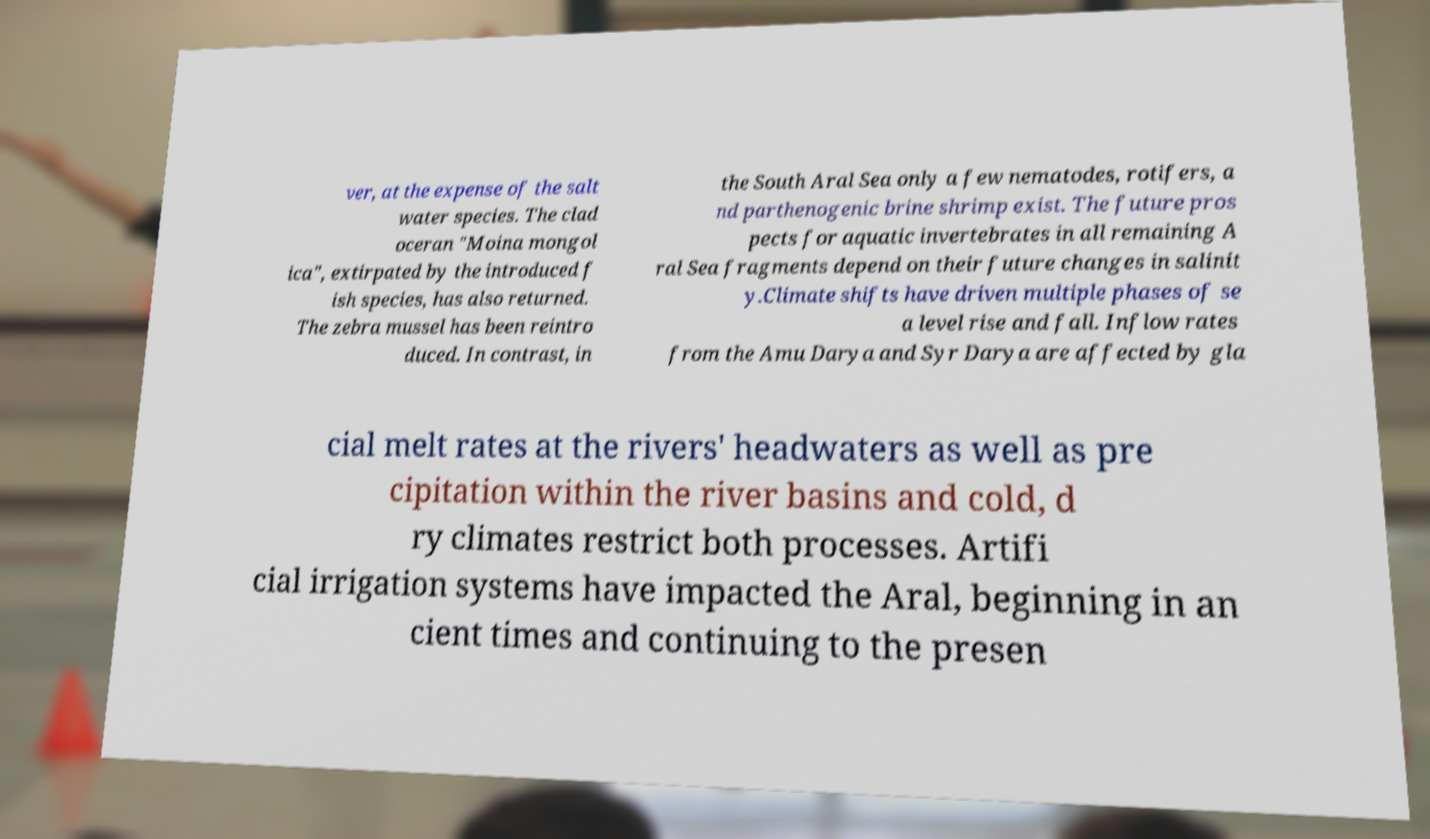What messages or text are displayed in this image? I need them in a readable, typed format. ver, at the expense of the salt water species. The clad oceran "Moina mongol ica", extirpated by the introduced f ish species, has also returned. The zebra mussel has been reintro duced. In contrast, in the South Aral Sea only a few nematodes, rotifers, a nd parthenogenic brine shrimp exist. The future pros pects for aquatic invertebrates in all remaining A ral Sea fragments depend on their future changes in salinit y.Climate shifts have driven multiple phases of se a level rise and fall. Inflow rates from the Amu Darya and Syr Darya are affected by gla cial melt rates at the rivers' headwaters as well as pre cipitation within the river basins and cold, d ry climates restrict both processes. Artifi cial irrigation systems have impacted the Aral, beginning in an cient times and continuing to the presen 